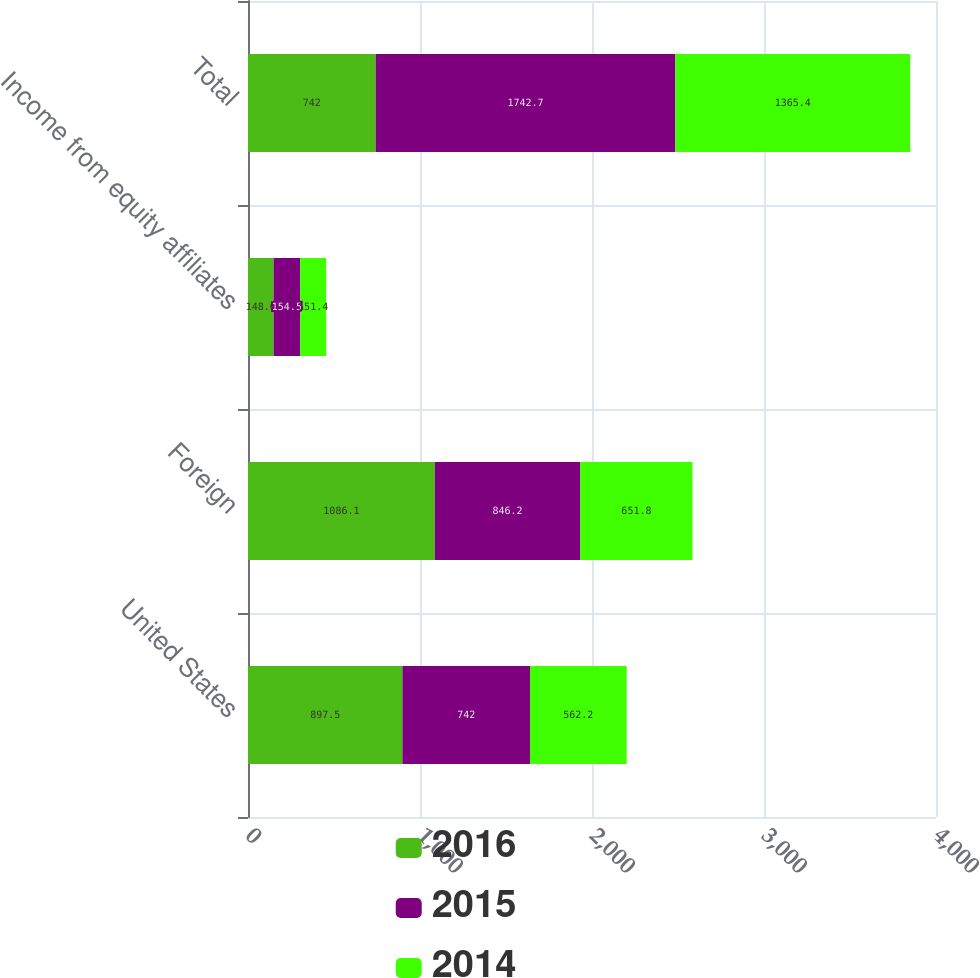<chart> <loc_0><loc_0><loc_500><loc_500><stacked_bar_chart><ecel><fcel>United States<fcel>Foreign<fcel>Income from equity affiliates<fcel>Total<nl><fcel>2016<fcel>897.5<fcel>1086.1<fcel>148.6<fcel>742<nl><fcel>2015<fcel>742<fcel>846.2<fcel>154.5<fcel>1742.7<nl><fcel>2014<fcel>562.2<fcel>651.8<fcel>151.4<fcel>1365.4<nl></chart> 